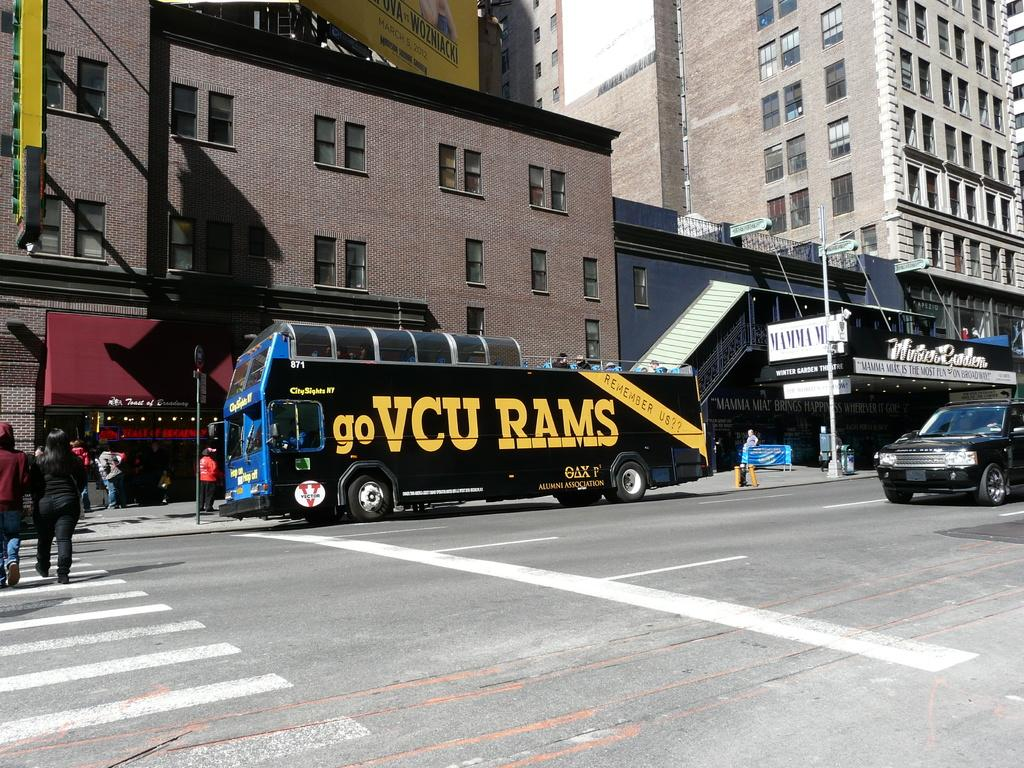What type of structures can be seen in the image? There are buildings in the image. What is happening on the road in the image? There are vehicles on the road and people walking in the image. What is the purpose of the pole in the image? The pole in the image is likely supporting a street light. What is the board in the image used for? The purpose of the board in the image is not clear, but it could be a sign or advertisement. What can be seen in the sky in the image? The sky is visible in the image, but no specific details about the sky are mentioned. What condition is the picture in? The condition of the picture itself is not mentioned in the facts, but it is likely in good condition since it is being described. Can you see anyone smashing the street light in the image? No, there is no indication of anyone smashing the street light in the image. 